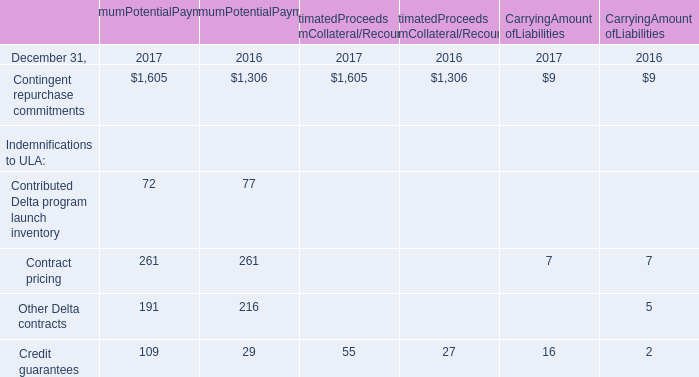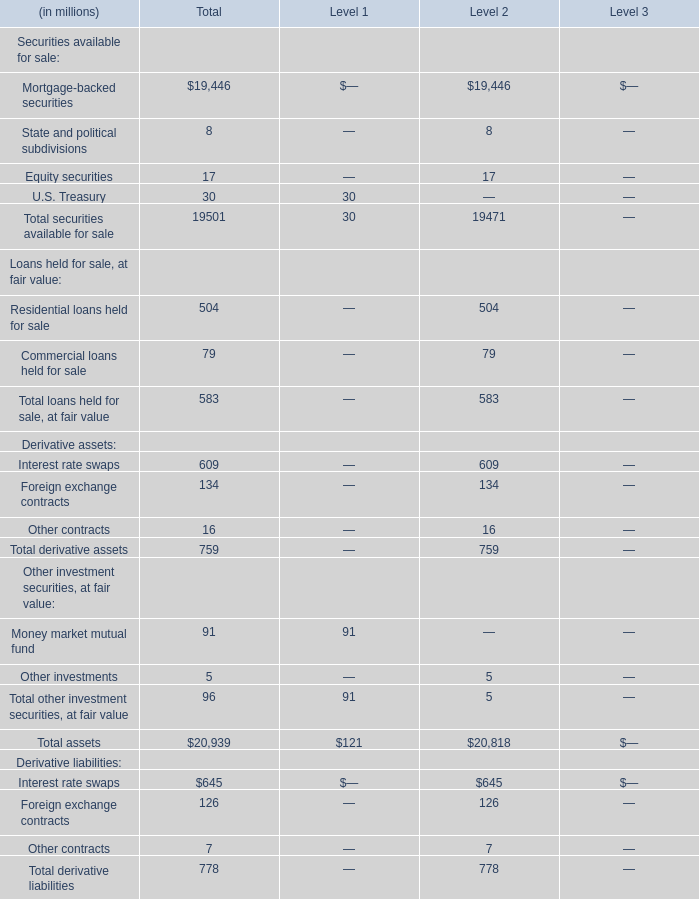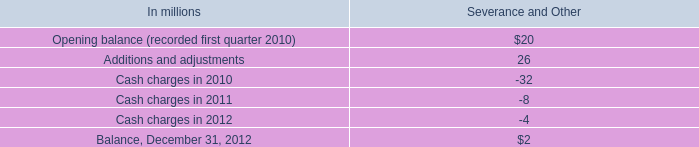Which Securities available for sale makes up more than 0.05% of total securities available for sale in Level 2? 
Answer: Mortgage-backed securities, Equity securities. 